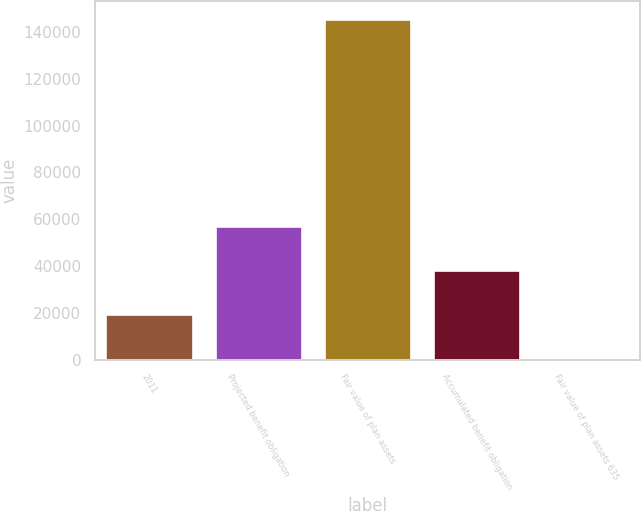Convert chart. <chart><loc_0><loc_0><loc_500><loc_500><bar_chart><fcel>2011<fcel>Projected benefit obligation<fcel>Fair value of plan assets<fcel>Accumulated benefit obligation<fcel>Fair value of plan assets 635<nl><fcel>19415.9<fcel>57043.7<fcel>145789<fcel>38229.8<fcel>602<nl></chart> 